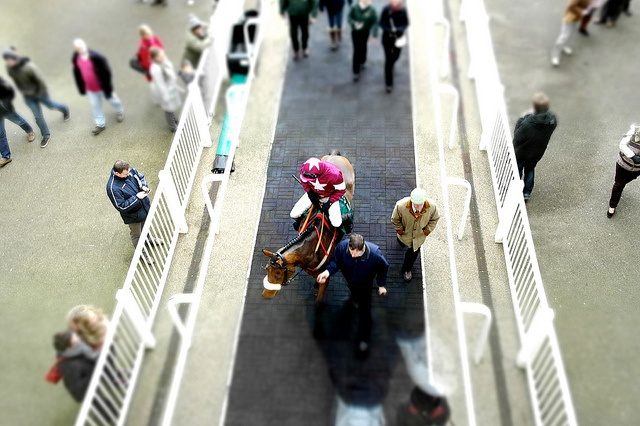Describe the objects in this image and their specific colors. I can see horse in lightgray, black, white, maroon, and gray tones, people in lightgray, black, navy, gray, and darkgray tones, people in lightgray, darkgray, black, and gray tones, people in lightgray, black, darkgray, and gray tones, and people in lightgray, black, gray, and white tones in this image. 